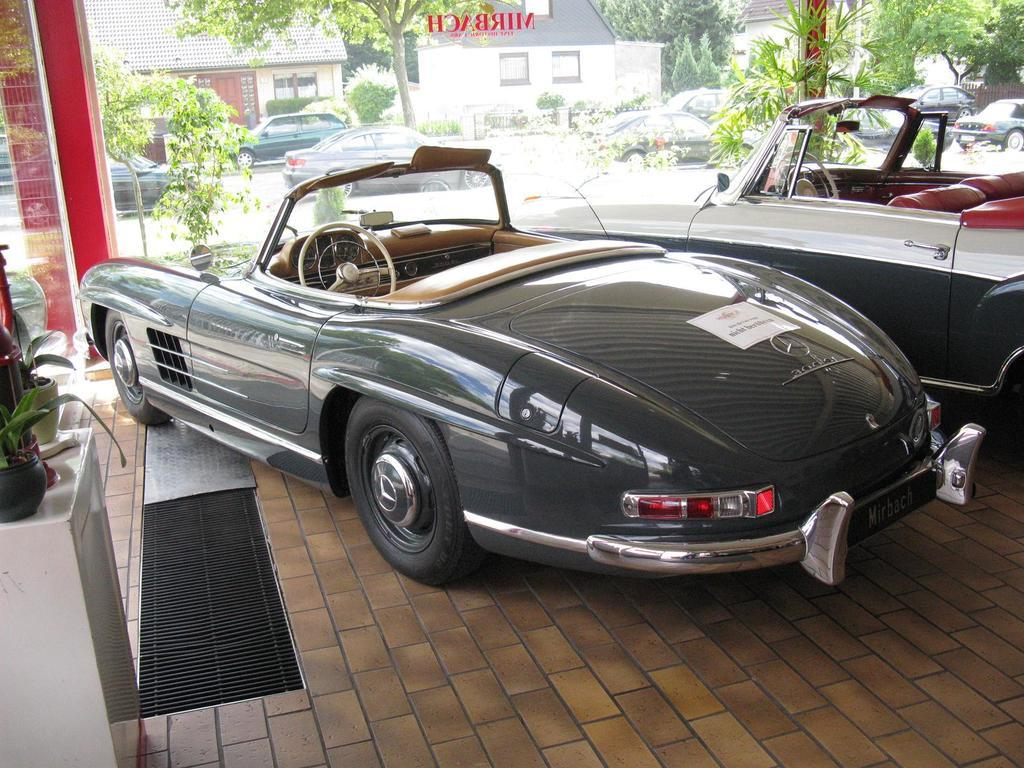What can be seen in the image? There are vehicles in the image. Where are the flower pots located in the image? The flower pots are on the left side of the image. What is visible through the glass in the image? Trees, vehicles on the road, and houses are visible through the glass. Can you tell me how many berries are on the memory of the chicken in the image? There are no berries, memories, or chickens present in the image. 